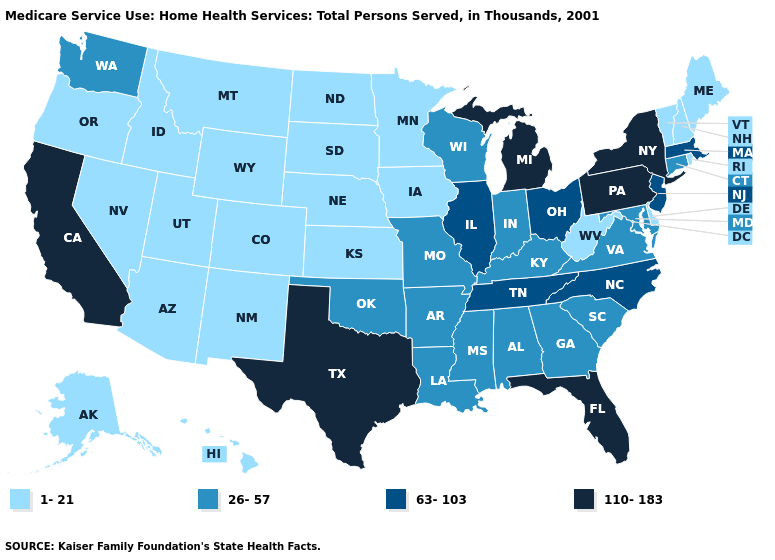Among the states that border Texas , does New Mexico have the lowest value?
Quick response, please. Yes. What is the value of South Dakota?
Quick response, please. 1-21. What is the value of Tennessee?
Short answer required. 63-103. How many symbols are there in the legend?
Concise answer only. 4. Does Vermont have the lowest value in the USA?
Give a very brief answer. Yes. Name the states that have a value in the range 26-57?
Keep it brief. Alabama, Arkansas, Connecticut, Georgia, Indiana, Kentucky, Louisiana, Maryland, Mississippi, Missouri, Oklahoma, South Carolina, Virginia, Washington, Wisconsin. Does New Mexico have a lower value than Delaware?
Answer briefly. No. What is the highest value in the South ?
Quick response, please. 110-183. Does Connecticut have the highest value in the USA?
Be succinct. No. Does the map have missing data?
Quick response, please. No. Among the states that border Missouri , does Iowa have the lowest value?
Be succinct. Yes. Does Wyoming have a lower value than Idaho?
Keep it brief. No. What is the value of California?
Give a very brief answer. 110-183. Name the states that have a value in the range 26-57?
Give a very brief answer. Alabama, Arkansas, Connecticut, Georgia, Indiana, Kentucky, Louisiana, Maryland, Mississippi, Missouri, Oklahoma, South Carolina, Virginia, Washington, Wisconsin. 